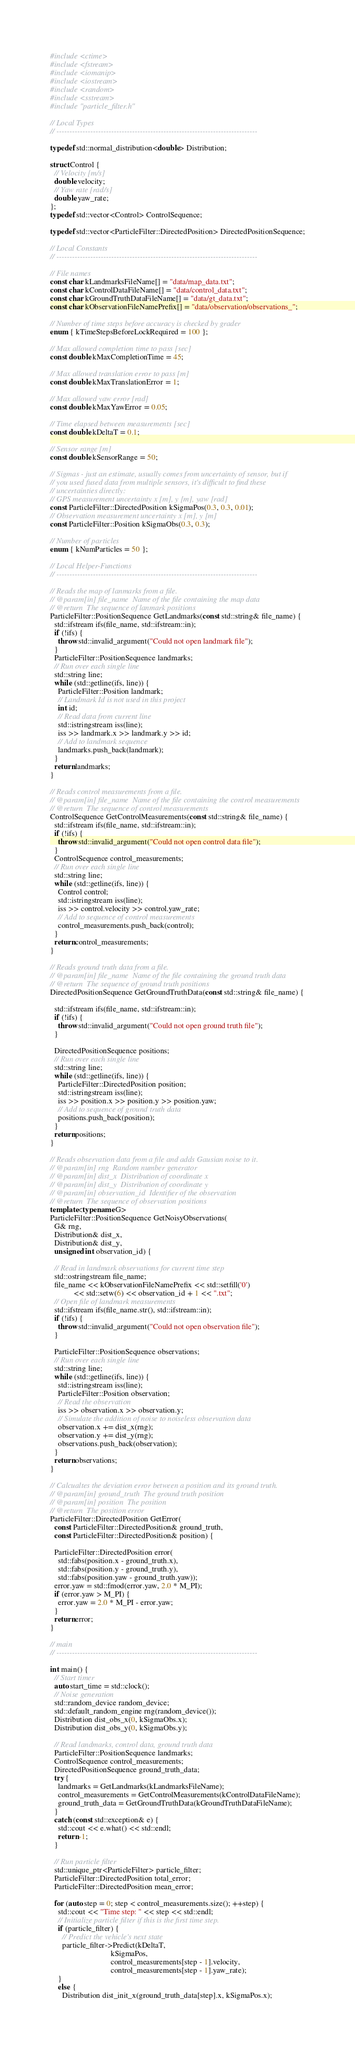<code> <loc_0><loc_0><loc_500><loc_500><_C++_>#include <ctime>
#include <fstream>
#include <iomanip>
#include <iostream>
#include <random>
#include <sstream>
#include "particle_filter.h"

// Local Types
// -----------------------------------------------------------------------------

typedef std::normal_distribution<double> Distribution;

struct Control {
  // Velocity [m/s]
  double velocity;
  // Yaw rate [rad/s]
  double yaw_rate;
};
typedef std::vector<Control> ControlSequence;

typedef std::vector<ParticleFilter::DirectedPosition> DirectedPositionSequence;

// Local Constants
// -----------------------------------------------------------------------------

// File names
const char kLandmarksFileName[] = "data/map_data.txt";
const char kControlDataFileName[] = "data/control_data.txt";
const char kGroundTruthDataFileName[] = "data/gt_data.txt";
const char kObservationFileNamePrefix[] = "data/observation/observations_";

// Number of time steps before accuracy is checked by grader
enum { kTimeStepsBeforeLockRequired = 100 };

// Max allowed completion time to pass [sec]
const double kMaxCompletionTime = 45;

// Max allowed translation error to pass [m]
const double kMaxTranslationError = 1;

// Max allowed yaw error [rad]
const double kMaxYawError = 0.05;

// Time elapsed between measurements [sec]
const double kDeltaT = 0.1;

// Sensor range [m]
const double kSensorRange = 50;

// Sigmas - just an estimate, usually comes from uncertainty of sensor, but if
// you used fused data from multiple sensors, it's difficult to find these
// uncertainties directly:
// GPS measurement uncertainty x [m], y [m], yaw [rad]
const ParticleFilter::DirectedPosition kSigmaPos(0.3, 0.3, 0.01);
// Observation measurement uncertainty x [m], y [m]
const ParticleFilter::Position kSigmaObs(0.3, 0.3);

// Number of particles
enum { kNumParticles = 50 };

// Local Helper-Functions
// -----------------------------------------------------------------------------

// Reads the map of lanmarks from a file.
// @param[in] file_name  Name of the file containing the map data
// @return  The sequence of lanmark positions
ParticleFilter::PositionSequence GetLandmarks(const std::string& file_name) {
  std::ifstream ifs(file_name, std::ifstream::in);
  if (!ifs) {
    throw std::invalid_argument("Could not open landmark file");
  }
  ParticleFilter::PositionSequence landmarks;
  // Run over each single line
  std::string line;
  while (std::getline(ifs, line)) {
    ParticleFilter::Position landmark;
    // Landmark Id is not used in this project
    int id;
    // Read data from current line
    std::istringstream iss(line);
    iss >> landmark.x >> landmark.y >> id;
    // Add to landmark sequence
    landmarks.push_back(landmark);
  }
  return landmarks;
}

// Reads control measurements from a file.
// @param[in] file_name  Name of the file containing the control measurements
// @return  The sequence of control measurements
ControlSequence GetControlMeasurements(const std::string& file_name) {
  std::ifstream ifs(file_name, std::ifstream::in);
  if (!ifs) {
    throw std::invalid_argument("Could not open control data file");
  }
  ControlSequence control_measurements;
  // Run over each single line
  std::string line;
  while (std::getline(ifs, line)) {
    Control control;
    std::istringstream iss(line);
    iss >> control.velocity >> control.yaw_rate;
    // Add to sequence of control measurements
    control_measurements.push_back(control);
  }
  return control_measurements;
}

// Reads ground truth data from a file.
// @param[in] file_name  Name of the file containing the ground truth data
// @return  The sequence of ground truth positions
DirectedPositionSequence GetGroundTruthData(const std::string& file_name) {

  std::ifstream ifs(file_name, std::ifstream::in);
  if (!ifs) {
    throw std::invalid_argument("Could not open ground truth file");
  }

  DirectedPositionSequence positions;
  // Run over each single line
  std::string line;
  while (std::getline(ifs, line)) {
    ParticleFilter::DirectedPosition position;
    std::istringstream iss(line);
    iss >> position.x >> position.y >> position.yaw;
    // Add to sequence of ground truth data
    positions.push_back(position);
  }
  return positions;
}

// Reads observation data from a file and adds Gausian noise to it.
// @param[in] rng  Random number generator
// @param[in] dist_x  Distribution of coordinate x
// @param[in] dist_y  Distribution of coordinate y
// @param[in] observation_id  Identifier of the observation
// @return  The sequence of observation positions
template<typename G>
ParticleFilter::PositionSequence GetNoisyObservations(
  G& rng,
  Distribution& dist_x,
  Distribution& dist_y,
  unsigned int observation_id) {

  // Read in landmark observations for current time step
  std::ostringstream file_name;
  file_name << kObservationFileNamePrefix << std::setfill('0')
            << std::setw(6) << observation_id + 1 << ".txt";
  // Open file of landmark measurements
  std::ifstream ifs(file_name.str(), std::ifstream::in);
  if (!ifs) {
    throw std::invalid_argument("Could not open observation file");
  }

  ParticleFilter::PositionSequence observations;
  // Run over each single line
  std::string line;
  while (std::getline(ifs, line)) {
    std::istringstream iss(line);
    ParticleFilter::Position observation;
    // Read the observation
    iss >> observation.x >> observation.y;
    // Simulate the addition of noise to noiseless observation data
    observation.x += dist_x(rng);
    observation.y += dist_y(rng);
    observations.push_back(observation);
  }
  return observations;
}

// Calcualtes the deviation error between a position and its ground truth.
// @param[in] ground_truth  The ground truth position
// @param[in] position  The position
// @return  The position error
ParticleFilter::DirectedPosition GetError(
  const ParticleFilter::DirectedPosition& ground_truth,
  const ParticleFilter::DirectedPosition& position) {

  ParticleFilter::DirectedPosition error(
    std::fabs(position.x - ground_truth.x),
    std::fabs(position.y - ground_truth.y),
    std::fabs(position.yaw - ground_truth.yaw));
  error.yaw = std::fmod(error.yaw, 2.0 * M_PI);
  if (error.yaw > M_PI) {
    error.yaw = 2.0 * M_PI - error.yaw;
  }
  return error;
}

// main
// -----------------------------------------------------------------------------

int main() {
  // Start timer
  auto start_time = std::clock();
  // Noise generation
  std::random_device random_device;
  std::default_random_engine rng(random_device());
  Distribution dist_obs_x(0, kSigmaObs.x);
  Distribution dist_obs_y(0, kSigmaObs.y);

  // Read landmarks, control data, ground truth data
  ParticleFilter::PositionSequence landmarks;
  ControlSequence control_measurements;
  DirectedPositionSequence ground_truth_data;
  try {
    landmarks = GetLandmarks(kLandmarksFileName);
    control_measurements = GetControlMeasurements(kControlDataFileName);
    ground_truth_data = GetGroundTruthData(kGroundTruthDataFileName);
  }
  catch (const std::exception& e) {
    std::cout << e.what() << std::endl;
    return -1;
  }

  // Run particle filter
  std::unique_ptr<ParticleFilter> particle_filter;
  ParticleFilter::DirectedPosition total_error;
  ParticleFilter::DirectedPosition mean_error;

  for (auto step = 0; step < control_measurements.size(); ++step) {
    std::cout << "Time step: " << step << std::endl;
    // Initialize particle filter if this is the first time step.
    if (particle_filter) {
      // Predict the vehicle's next state
      particle_filter->Predict(kDeltaT,
                               kSigmaPos,
                               control_measurements[step - 1].velocity,
                               control_measurements[step - 1].yaw_rate);
    }
    else {
      Distribution dist_init_x(ground_truth_data[step].x, kSigmaPos.x);</code> 